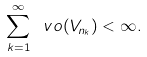<formula> <loc_0><loc_0><loc_500><loc_500>\sum _ { k = 1 } ^ { \infty } \ v o ( V _ { n _ { k } } ) < \infty .</formula> 